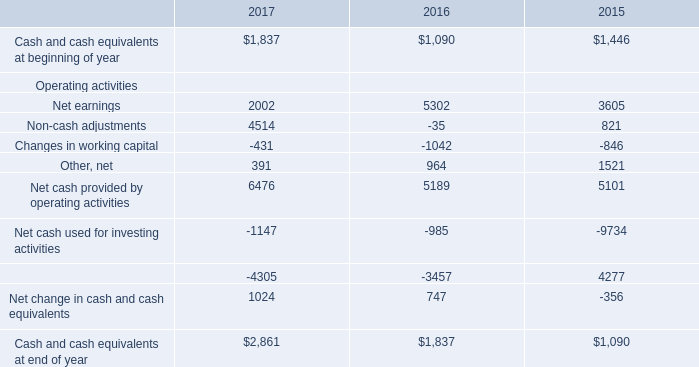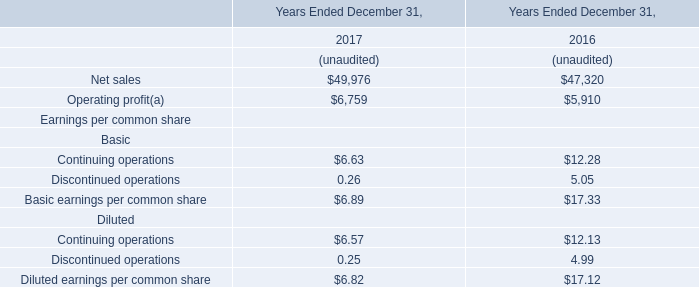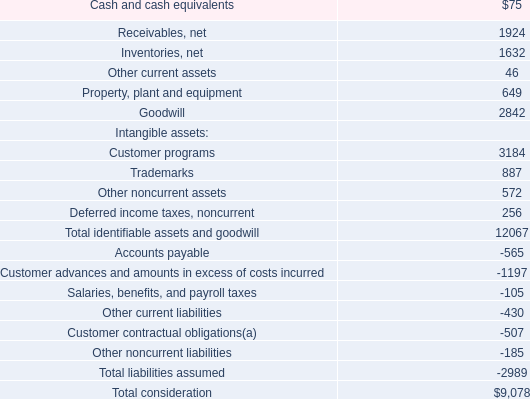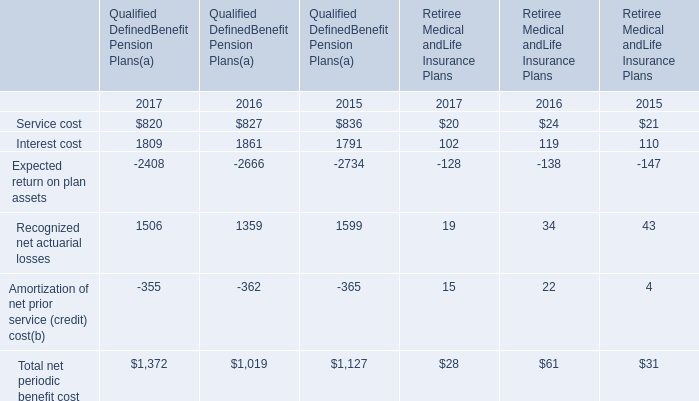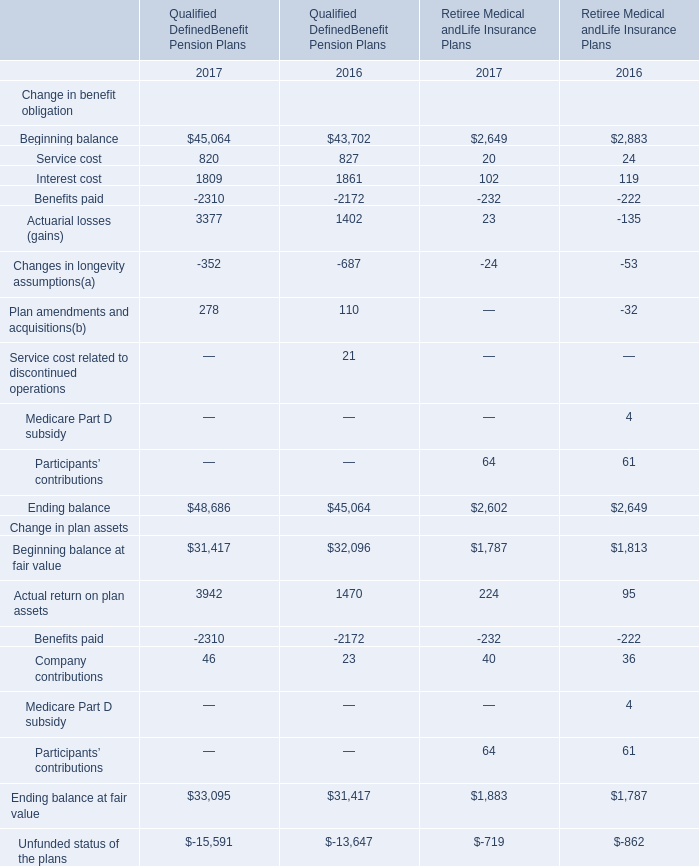Does the value of Beginning balance in 2016 greater than that in 2017 for Qualified DefinedBenefit Pension Plans? 
Answer: no. 